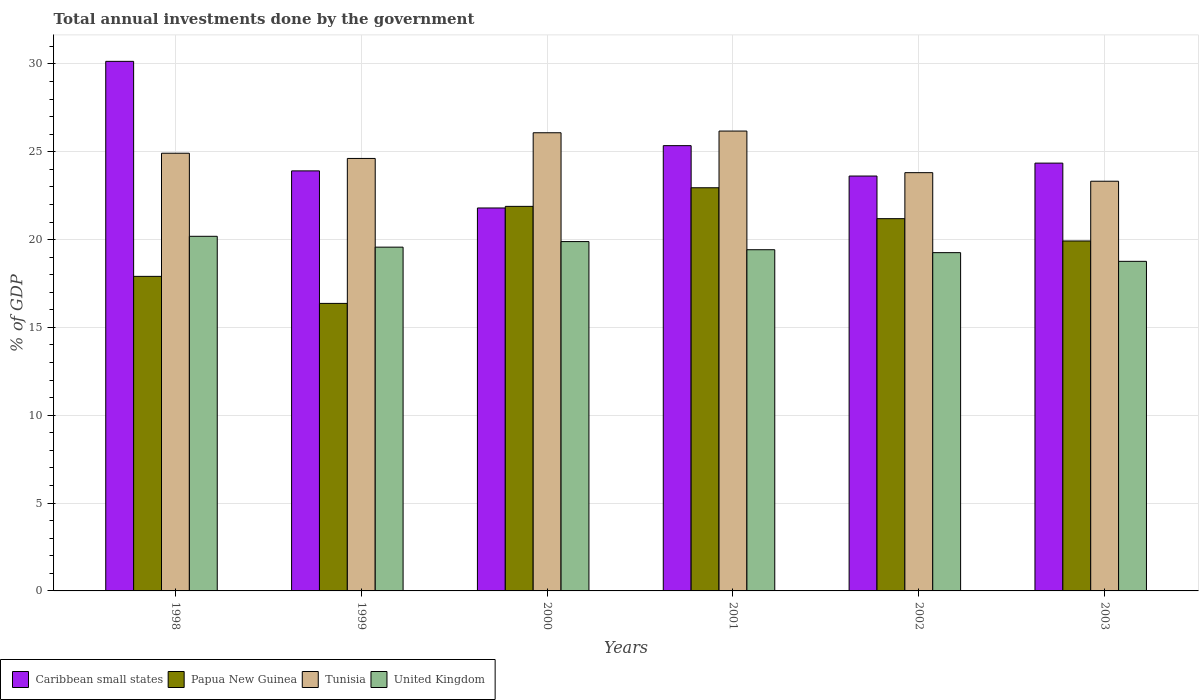How many different coloured bars are there?
Offer a very short reply. 4. How many groups of bars are there?
Make the answer very short. 6. Are the number of bars on each tick of the X-axis equal?
Your answer should be very brief. Yes. How many bars are there on the 3rd tick from the left?
Offer a terse response. 4. How many bars are there on the 5th tick from the right?
Offer a terse response. 4. What is the total annual investments done by the government in Tunisia in 2002?
Provide a short and direct response. 23.81. Across all years, what is the maximum total annual investments done by the government in Papua New Guinea?
Make the answer very short. 22.95. Across all years, what is the minimum total annual investments done by the government in Caribbean small states?
Keep it short and to the point. 21.8. In which year was the total annual investments done by the government in Tunisia minimum?
Keep it short and to the point. 2003. What is the total total annual investments done by the government in Caribbean small states in the graph?
Ensure brevity in your answer.  149.18. What is the difference between the total annual investments done by the government in United Kingdom in 1998 and that in 2000?
Offer a terse response. 0.3. What is the difference between the total annual investments done by the government in Tunisia in 1998 and the total annual investments done by the government in Papua New Guinea in 1999?
Provide a short and direct response. 8.55. What is the average total annual investments done by the government in United Kingdom per year?
Provide a short and direct response. 19.51. In the year 1998, what is the difference between the total annual investments done by the government in Papua New Guinea and total annual investments done by the government in United Kingdom?
Keep it short and to the point. -2.28. In how many years, is the total annual investments done by the government in Caribbean small states greater than 28 %?
Keep it short and to the point. 1. What is the ratio of the total annual investments done by the government in Tunisia in 2000 to that in 2002?
Ensure brevity in your answer.  1.1. What is the difference between the highest and the second highest total annual investments done by the government in United Kingdom?
Make the answer very short. 0.3. What is the difference between the highest and the lowest total annual investments done by the government in Papua New Guinea?
Ensure brevity in your answer.  6.58. In how many years, is the total annual investments done by the government in Tunisia greater than the average total annual investments done by the government in Tunisia taken over all years?
Make the answer very short. 3. What does the 2nd bar from the right in 2001 represents?
Make the answer very short. Tunisia. How many bars are there?
Your answer should be compact. 24. Are all the bars in the graph horizontal?
Your answer should be compact. No. How many years are there in the graph?
Keep it short and to the point. 6. Does the graph contain grids?
Your answer should be very brief. Yes. Where does the legend appear in the graph?
Make the answer very short. Bottom left. What is the title of the graph?
Your response must be concise. Total annual investments done by the government. Does "Ethiopia" appear as one of the legend labels in the graph?
Keep it short and to the point. No. What is the label or title of the Y-axis?
Ensure brevity in your answer.  % of GDP. What is the % of GDP of Caribbean small states in 1998?
Provide a short and direct response. 30.15. What is the % of GDP in Papua New Guinea in 1998?
Your answer should be very brief. 17.91. What is the % of GDP in Tunisia in 1998?
Provide a succinct answer. 24.92. What is the % of GDP of United Kingdom in 1998?
Keep it short and to the point. 20.19. What is the % of GDP in Caribbean small states in 1999?
Your answer should be compact. 23.91. What is the % of GDP of Papua New Guinea in 1999?
Provide a short and direct response. 16.37. What is the % of GDP in Tunisia in 1999?
Keep it short and to the point. 24.62. What is the % of GDP of United Kingdom in 1999?
Your answer should be very brief. 19.57. What is the % of GDP in Caribbean small states in 2000?
Provide a succinct answer. 21.8. What is the % of GDP in Papua New Guinea in 2000?
Keep it short and to the point. 21.89. What is the % of GDP in Tunisia in 2000?
Your response must be concise. 26.08. What is the % of GDP of United Kingdom in 2000?
Ensure brevity in your answer.  19.89. What is the % of GDP in Caribbean small states in 2001?
Offer a very short reply. 25.35. What is the % of GDP in Papua New Guinea in 2001?
Your response must be concise. 22.95. What is the % of GDP in Tunisia in 2001?
Provide a succinct answer. 26.18. What is the % of GDP of United Kingdom in 2001?
Provide a succinct answer. 19.42. What is the % of GDP in Caribbean small states in 2002?
Your answer should be very brief. 23.62. What is the % of GDP of Papua New Guinea in 2002?
Your answer should be compact. 21.19. What is the % of GDP of Tunisia in 2002?
Ensure brevity in your answer.  23.81. What is the % of GDP in United Kingdom in 2002?
Keep it short and to the point. 19.26. What is the % of GDP of Caribbean small states in 2003?
Offer a very short reply. 24.35. What is the % of GDP in Papua New Guinea in 2003?
Make the answer very short. 19.92. What is the % of GDP in Tunisia in 2003?
Your answer should be very brief. 23.32. What is the % of GDP of United Kingdom in 2003?
Ensure brevity in your answer.  18.76. Across all years, what is the maximum % of GDP in Caribbean small states?
Offer a terse response. 30.15. Across all years, what is the maximum % of GDP in Papua New Guinea?
Provide a succinct answer. 22.95. Across all years, what is the maximum % of GDP in Tunisia?
Offer a very short reply. 26.18. Across all years, what is the maximum % of GDP in United Kingdom?
Your answer should be compact. 20.19. Across all years, what is the minimum % of GDP in Caribbean small states?
Your response must be concise. 21.8. Across all years, what is the minimum % of GDP of Papua New Guinea?
Provide a short and direct response. 16.37. Across all years, what is the minimum % of GDP in Tunisia?
Offer a terse response. 23.32. Across all years, what is the minimum % of GDP of United Kingdom?
Provide a succinct answer. 18.76. What is the total % of GDP of Caribbean small states in the graph?
Your response must be concise. 149.18. What is the total % of GDP of Papua New Guinea in the graph?
Your answer should be compact. 120.23. What is the total % of GDP of Tunisia in the graph?
Make the answer very short. 148.93. What is the total % of GDP in United Kingdom in the graph?
Make the answer very short. 117.09. What is the difference between the % of GDP in Caribbean small states in 1998 and that in 1999?
Provide a short and direct response. 6.24. What is the difference between the % of GDP in Papua New Guinea in 1998 and that in 1999?
Provide a succinct answer. 1.54. What is the difference between the % of GDP in Tunisia in 1998 and that in 1999?
Offer a very short reply. 0.3. What is the difference between the % of GDP in United Kingdom in 1998 and that in 1999?
Ensure brevity in your answer.  0.62. What is the difference between the % of GDP of Caribbean small states in 1998 and that in 2000?
Your answer should be compact. 8.35. What is the difference between the % of GDP of Papua New Guinea in 1998 and that in 2000?
Make the answer very short. -3.99. What is the difference between the % of GDP of Tunisia in 1998 and that in 2000?
Give a very brief answer. -1.17. What is the difference between the % of GDP in United Kingdom in 1998 and that in 2000?
Your response must be concise. 0.3. What is the difference between the % of GDP of Caribbean small states in 1998 and that in 2001?
Make the answer very short. 4.8. What is the difference between the % of GDP in Papua New Guinea in 1998 and that in 2001?
Your response must be concise. -5.05. What is the difference between the % of GDP in Tunisia in 1998 and that in 2001?
Offer a terse response. -1.26. What is the difference between the % of GDP of United Kingdom in 1998 and that in 2001?
Make the answer very short. 0.76. What is the difference between the % of GDP in Caribbean small states in 1998 and that in 2002?
Your answer should be compact. 6.53. What is the difference between the % of GDP of Papua New Guinea in 1998 and that in 2002?
Your answer should be very brief. -3.29. What is the difference between the % of GDP in Tunisia in 1998 and that in 2002?
Ensure brevity in your answer.  1.11. What is the difference between the % of GDP in United Kingdom in 1998 and that in 2002?
Provide a short and direct response. 0.93. What is the difference between the % of GDP in Caribbean small states in 1998 and that in 2003?
Your response must be concise. 5.79. What is the difference between the % of GDP of Papua New Guinea in 1998 and that in 2003?
Ensure brevity in your answer.  -2.01. What is the difference between the % of GDP of Tunisia in 1998 and that in 2003?
Your response must be concise. 1.59. What is the difference between the % of GDP in United Kingdom in 1998 and that in 2003?
Give a very brief answer. 1.42. What is the difference between the % of GDP in Caribbean small states in 1999 and that in 2000?
Make the answer very short. 2.11. What is the difference between the % of GDP in Papua New Guinea in 1999 and that in 2000?
Offer a terse response. -5.52. What is the difference between the % of GDP in Tunisia in 1999 and that in 2000?
Offer a terse response. -1.46. What is the difference between the % of GDP in United Kingdom in 1999 and that in 2000?
Your answer should be very brief. -0.32. What is the difference between the % of GDP in Caribbean small states in 1999 and that in 2001?
Offer a very short reply. -1.44. What is the difference between the % of GDP of Papua New Guinea in 1999 and that in 2001?
Ensure brevity in your answer.  -6.58. What is the difference between the % of GDP of Tunisia in 1999 and that in 2001?
Make the answer very short. -1.56. What is the difference between the % of GDP in United Kingdom in 1999 and that in 2001?
Your response must be concise. 0.15. What is the difference between the % of GDP of Caribbean small states in 1999 and that in 2002?
Keep it short and to the point. 0.29. What is the difference between the % of GDP of Papua New Guinea in 1999 and that in 2002?
Offer a terse response. -4.82. What is the difference between the % of GDP of Tunisia in 1999 and that in 2002?
Keep it short and to the point. 0.81. What is the difference between the % of GDP in United Kingdom in 1999 and that in 2002?
Provide a short and direct response. 0.31. What is the difference between the % of GDP in Caribbean small states in 1999 and that in 2003?
Keep it short and to the point. -0.44. What is the difference between the % of GDP of Papua New Guinea in 1999 and that in 2003?
Give a very brief answer. -3.55. What is the difference between the % of GDP in Tunisia in 1999 and that in 2003?
Your answer should be very brief. 1.3. What is the difference between the % of GDP of United Kingdom in 1999 and that in 2003?
Provide a short and direct response. 0.81. What is the difference between the % of GDP in Caribbean small states in 2000 and that in 2001?
Give a very brief answer. -3.55. What is the difference between the % of GDP of Papua New Guinea in 2000 and that in 2001?
Offer a very short reply. -1.06. What is the difference between the % of GDP of Tunisia in 2000 and that in 2001?
Offer a terse response. -0.1. What is the difference between the % of GDP in United Kingdom in 2000 and that in 2001?
Your answer should be very brief. 0.46. What is the difference between the % of GDP in Caribbean small states in 2000 and that in 2002?
Ensure brevity in your answer.  -1.82. What is the difference between the % of GDP in Tunisia in 2000 and that in 2002?
Offer a very short reply. 2.27. What is the difference between the % of GDP of United Kingdom in 2000 and that in 2002?
Keep it short and to the point. 0.63. What is the difference between the % of GDP of Caribbean small states in 2000 and that in 2003?
Your response must be concise. -2.55. What is the difference between the % of GDP of Papua New Guinea in 2000 and that in 2003?
Your answer should be very brief. 1.97. What is the difference between the % of GDP of Tunisia in 2000 and that in 2003?
Offer a terse response. 2.76. What is the difference between the % of GDP in United Kingdom in 2000 and that in 2003?
Make the answer very short. 1.12. What is the difference between the % of GDP in Caribbean small states in 2001 and that in 2002?
Make the answer very short. 1.73. What is the difference between the % of GDP in Papua New Guinea in 2001 and that in 2002?
Offer a terse response. 1.76. What is the difference between the % of GDP in Tunisia in 2001 and that in 2002?
Offer a terse response. 2.37. What is the difference between the % of GDP of United Kingdom in 2001 and that in 2002?
Make the answer very short. 0.17. What is the difference between the % of GDP of Papua New Guinea in 2001 and that in 2003?
Your response must be concise. 3.03. What is the difference between the % of GDP of Tunisia in 2001 and that in 2003?
Ensure brevity in your answer.  2.86. What is the difference between the % of GDP in United Kingdom in 2001 and that in 2003?
Provide a succinct answer. 0.66. What is the difference between the % of GDP of Caribbean small states in 2002 and that in 2003?
Make the answer very short. -0.74. What is the difference between the % of GDP of Papua New Guinea in 2002 and that in 2003?
Make the answer very short. 1.27. What is the difference between the % of GDP of Tunisia in 2002 and that in 2003?
Keep it short and to the point. 0.49. What is the difference between the % of GDP in United Kingdom in 2002 and that in 2003?
Keep it short and to the point. 0.49. What is the difference between the % of GDP of Caribbean small states in 1998 and the % of GDP of Papua New Guinea in 1999?
Give a very brief answer. 13.78. What is the difference between the % of GDP of Caribbean small states in 1998 and the % of GDP of Tunisia in 1999?
Provide a short and direct response. 5.53. What is the difference between the % of GDP of Caribbean small states in 1998 and the % of GDP of United Kingdom in 1999?
Give a very brief answer. 10.58. What is the difference between the % of GDP in Papua New Guinea in 1998 and the % of GDP in Tunisia in 1999?
Offer a very short reply. -6.71. What is the difference between the % of GDP in Papua New Guinea in 1998 and the % of GDP in United Kingdom in 1999?
Offer a terse response. -1.66. What is the difference between the % of GDP of Tunisia in 1998 and the % of GDP of United Kingdom in 1999?
Offer a terse response. 5.35. What is the difference between the % of GDP of Caribbean small states in 1998 and the % of GDP of Papua New Guinea in 2000?
Provide a short and direct response. 8.26. What is the difference between the % of GDP in Caribbean small states in 1998 and the % of GDP in Tunisia in 2000?
Your response must be concise. 4.06. What is the difference between the % of GDP of Caribbean small states in 1998 and the % of GDP of United Kingdom in 2000?
Offer a terse response. 10.26. What is the difference between the % of GDP in Papua New Guinea in 1998 and the % of GDP in Tunisia in 2000?
Offer a terse response. -8.18. What is the difference between the % of GDP of Papua New Guinea in 1998 and the % of GDP of United Kingdom in 2000?
Keep it short and to the point. -1.98. What is the difference between the % of GDP in Tunisia in 1998 and the % of GDP in United Kingdom in 2000?
Provide a short and direct response. 5.03. What is the difference between the % of GDP of Caribbean small states in 1998 and the % of GDP of Papua New Guinea in 2001?
Your response must be concise. 7.2. What is the difference between the % of GDP of Caribbean small states in 1998 and the % of GDP of Tunisia in 2001?
Offer a terse response. 3.97. What is the difference between the % of GDP in Caribbean small states in 1998 and the % of GDP in United Kingdom in 2001?
Your answer should be compact. 10.72. What is the difference between the % of GDP in Papua New Guinea in 1998 and the % of GDP in Tunisia in 2001?
Ensure brevity in your answer.  -8.27. What is the difference between the % of GDP of Papua New Guinea in 1998 and the % of GDP of United Kingdom in 2001?
Ensure brevity in your answer.  -1.52. What is the difference between the % of GDP in Tunisia in 1998 and the % of GDP in United Kingdom in 2001?
Your answer should be very brief. 5.49. What is the difference between the % of GDP in Caribbean small states in 1998 and the % of GDP in Papua New Guinea in 2002?
Provide a short and direct response. 8.96. What is the difference between the % of GDP of Caribbean small states in 1998 and the % of GDP of Tunisia in 2002?
Ensure brevity in your answer.  6.34. What is the difference between the % of GDP of Caribbean small states in 1998 and the % of GDP of United Kingdom in 2002?
Provide a succinct answer. 10.89. What is the difference between the % of GDP in Papua New Guinea in 1998 and the % of GDP in Tunisia in 2002?
Offer a very short reply. -5.9. What is the difference between the % of GDP of Papua New Guinea in 1998 and the % of GDP of United Kingdom in 2002?
Your answer should be very brief. -1.35. What is the difference between the % of GDP in Tunisia in 1998 and the % of GDP in United Kingdom in 2002?
Your response must be concise. 5.66. What is the difference between the % of GDP in Caribbean small states in 1998 and the % of GDP in Papua New Guinea in 2003?
Provide a succinct answer. 10.23. What is the difference between the % of GDP of Caribbean small states in 1998 and the % of GDP of Tunisia in 2003?
Your answer should be compact. 6.82. What is the difference between the % of GDP of Caribbean small states in 1998 and the % of GDP of United Kingdom in 2003?
Offer a very short reply. 11.38. What is the difference between the % of GDP in Papua New Guinea in 1998 and the % of GDP in Tunisia in 2003?
Offer a terse response. -5.42. What is the difference between the % of GDP of Papua New Guinea in 1998 and the % of GDP of United Kingdom in 2003?
Give a very brief answer. -0.86. What is the difference between the % of GDP in Tunisia in 1998 and the % of GDP in United Kingdom in 2003?
Make the answer very short. 6.15. What is the difference between the % of GDP in Caribbean small states in 1999 and the % of GDP in Papua New Guinea in 2000?
Offer a terse response. 2.02. What is the difference between the % of GDP of Caribbean small states in 1999 and the % of GDP of Tunisia in 2000?
Provide a short and direct response. -2.17. What is the difference between the % of GDP of Caribbean small states in 1999 and the % of GDP of United Kingdom in 2000?
Ensure brevity in your answer.  4.03. What is the difference between the % of GDP of Papua New Guinea in 1999 and the % of GDP of Tunisia in 2000?
Make the answer very short. -9.71. What is the difference between the % of GDP in Papua New Guinea in 1999 and the % of GDP in United Kingdom in 2000?
Your answer should be compact. -3.52. What is the difference between the % of GDP in Tunisia in 1999 and the % of GDP in United Kingdom in 2000?
Your response must be concise. 4.73. What is the difference between the % of GDP in Caribbean small states in 1999 and the % of GDP in Papua New Guinea in 2001?
Ensure brevity in your answer.  0.96. What is the difference between the % of GDP of Caribbean small states in 1999 and the % of GDP of Tunisia in 2001?
Provide a succinct answer. -2.27. What is the difference between the % of GDP in Caribbean small states in 1999 and the % of GDP in United Kingdom in 2001?
Your answer should be very brief. 4.49. What is the difference between the % of GDP in Papua New Guinea in 1999 and the % of GDP in Tunisia in 2001?
Provide a short and direct response. -9.81. What is the difference between the % of GDP in Papua New Guinea in 1999 and the % of GDP in United Kingdom in 2001?
Provide a short and direct response. -3.06. What is the difference between the % of GDP of Tunisia in 1999 and the % of GDP of United Kingdom in 2001?
Keep it short and to the point. 5.2. What is the difference between the % of GDP of Caribbean small states in 1999 and the % of GDP of Papua New Guinea in 2002?
Make the answer very short. 2.72. What is the difference between the % of GDP in Caribbean small states in 1999 and the % of GDP in Tunisia in 2002?
Make the answer very short. 0.1. What is the difference between the % of GDP in Caribbean small states in 1999 and the % of GDP in United Kingdom in 2002?
Make the answer very short. 4.66. What is the difference between the % of GDP in Papua New Guinea in 1999 and the % of GDP in Tunisia in 2002?
Provide a succinct answer. -7.44. What is the difference between the % of GDP in Papua New Guinea in 1999 and the % of GDP in United Kingdom in 2002?
Your answer should be very brief. -2.89. What is the difference between the % of GDP in Tunisia in 1999 and the % of GDP in United Kingdom in 2002?
Give a very brief answer. 5.36. What is the difference between the % of GDP in Caribbean small states in 1999 and the % of GDP in Papua New Guinea in 2003?
Make the answer very short. 3.99. What is the difference between the % of GDP in Caribbean small states in 1999 and the % of GDP in Tunisia in 2003?
Ensure brevity in your answer.  0.59. What is the difference between the % of GDP in Caribbean small states in 1999 and the % of GDP in United Kingdom in 2003?
Make the answer very short. 5.15. What is the difference between the % of GDP of Papua New Guinea in 1999 and the % of GDP of Tunisia in 2003?
Provide a short and direct response. -6.95. What is the difference between the % of GDP in Papua New Guinea in 1999 and the % of GDP in United Kingdom in 2003?
Offer a terse response. -2.39. What is the difference between the % of GDP in Tunisia in 1999 and the % of GDP in United Kingdom in 2003?
Keep it short and to the point. 5.86. What is the difference between the % of GDP in Caribbean small states in 2000 and the % of GDP in Papua New Guinea in 2001?
Offer a terse response. -1.15. What is the difference between the % of GDP of Caribbean small states in 2000 and the % of GDP of Tunisia in 2001?
Your answer should be compact. -4.38. What is the difference between the % of GDP of Caribbean small states in 2000 and the % of GDP of United Kingdom in 2001?
Your answer should be compact. 2.38. What is the difference between the % of GDP in Papua New Guinea in 2000 and the % of GDP in Tunisia in 2001?
Offer a very short reply. -4.29. What is the difference between the % of GDP in Papua New Guinea in 2000 and the % of GDP in United Kingdom in 2001?
Offer a very short reply. 2.47. What is the difference between the % of GDP of Tunisia in 2000 and the % of GDP of United Kingdom in 2001?
Offer a terse response. 6.66. What is the difference between the % of GDP in Caribbean small states in 2000 and the % of GDP in Papua New Guinea in 2002?
Your response must be concise. 0.61. What is the difference between the % of GDP in Caribbean small states in 2000 and the % of GDP in Tunisia in 2002?
Offer a terse response. -2.01. What is the difference between the % of GDP of Caribbean small states in 2000 and the % of GDP of United Kingdom in 2002?
Your response must be concise. 2.54. What is the difference between the % of GDP of Papua New Guinea in 2000 and the % of GDP of Tunisia in 2002?
Your answer should be very brief. -1.92. What is the difference between the % of GDP of Papua New Guinea in 2000 and the % of GDP of United Kingdom in 2002?
Provide a short and direct response. 2.63. What is the difference between the % of GDP in Tunisia in 2000 and the % of GDP in United Kingdom in 2002?
Make the answer very short. 6.83. What is the difference between the % of GDP of Caribbean small states in 2000 and the % of GDP of Papua New Guinea in 2003?
Provide a succinct answer. 1.88. What is the difference between the % of GDP of Caribbean small states in 2000 and the % of GDP of Tunisia in 2003?
Offer a very short reply. -1.52. What is the difference between the % of GDP in Caribbean small states in 2000 and the % of GDP in United Kingdom in 2003?
Provide a short and direct response. 3.04. What is the difference between the % of GDP of Papua New Guinea in 2000 and the % of GDP of Tunisia in 2003?
Offer a very short reply. -1.43. What is the difference between the % of GDP in Papua New Guinea in 2000 and the % of GDP in United Kingdom in 2003?
Offer a terse response. 3.13. What is the difference between the % of GDP of Tunisia in 2000 and the % of GDP of United Kingdom in 2003?
Ensure brevity in your answer.  7.32. What is the difference between the % of GDP in Caribbean small states in 2001 and the % of GDP in Papua New Guinea in 2002?
Give a very brief answer. 4.16. What is the difference between the % of GDP of Caribbean small states in 2001 and the % of GDP of Tunisia in 2002?
Ensure brevity in your answer.  1.54. What is the difference between the % of GDP in Caribbean small states in 2001 and the % of GDP in United Kingdom in 2002?
Provide a short and direct response. 6.09. What is the difference between the % of GDP of Papua New Guinea in 2001 and the % of GDP of Tunisia in 2002?
Offer a terse response. -0.86. What is the difference between the % of GDP in Papua New Guinea in 2001 and the % of GDP in United Kingdom in 2002?
Offer a very short reply. 3.69. What is the difference between the % of GDP in Tunisia in 2001 and the % of GDP in United Kingdom in 2002?
Your answer should be very brief. 6.92. What is the difference between the % of GDP of Caribbean small states in 2001 and the % of GDP of Papua New Guinea in 2003?
Provide a succinct answer. 5.43. What is the difference between the % of GDP in Caribbean small states in 2001 and the % of GDP in Tunisia in 2003?
Ensure brevity in your answer.  2.03. What is the difference between the % of GDP in Caribbean small states in 2001 and the % of GDP in United Kingdom in 2003?
Ensure brevity in your answer.  6.59. What is the difference between the % of GDP of Papua New Guinea in 2001 and the % of GDP of Tunisia in 2003?
Give a very brief answer. -0.37. What is the difference between the % of GDP of Papua New Guinea in 2001 and the % of GDP of United Kingdom in 2003?
Offer a very short reply. 4.19. What is the difference between the % of GDP in Tunisia in 2001 and the % of GDP in United Kingdom in 2003?
Your response must be concise. 7.42. What is the difference between the % of GDP of Caribbean small states in 2002 and the % of GDP of Papua New Guinea in 2003?
Give a very brief answer. 3.7. What is the difference between the % of GDP in Caribbean small states in 2002 and the % of GDP in Tunisia in 2003?
Your response must be concise. 0.3. What is the difference between the % of GDP of Caribbean small states in 2002 and the % of GDP of United Kingdom in 2003?
Your response must be concise. 4.86. What is the difference between the % of GDP in Papua New Guinea in 2002 and the % of GDP in Tunisia in 2003?
Ensure brevity in your answer.  -2.13. What is the difference between the % of GDP in Papua New Guinea in 2002 and the % of GDP in United Kingdom in 2003?
Provide a succinct answer. 2.43. What is the difference between the % of GDP of Tunisia in 2002 and the % of GDP of United Kingdom in 2003?
Your answer should be compact. 5.05. What is the average % of GDP in Caribbean small states per year?
Your answer should be compact. 24.86. What is the average % of GDP of Papua New Guinea per year?
Offer a terse response. 20.04. What is the average % of GDP of Tunisia per year?
Your response must be concise. 24.82. What is the average % of GDP in United Kingdom per year?
Offer a terse response. 19.51. In the year 1998, what is the difference between the % of GDP of Caribbean small states and % of GDP of Papua New Guinea?
Give a very brief answer. 12.24. In the year 1998, what is the difference between the % of GDP of Caribbean small states and % of GDP of Tunisia?
Your answer should be very brief. 5.23. In the year 1998, what is the difference between the % of GDP of Caribbean small states and % of GDP of United Kingdom?
Provide a succinct answer. 9.96. In the year 1998, what is the difference between the % of GDP of Papua New Guinea and % of GDP of Tunisia?
Your response must be concise. -7.01. In the year 1998, what is the difference between the % of GDP in Papua New Guinea and % of GDP in United Kingdom?
Your response must be concise. -2.28. In the year 1998, what is the difference between the % of GDP in Tunisia and % of GDP in United Kingdom?
Give a very brief answer. 4.73. In the year 1999, what is the difference between the % of GDP in Caribbean small states and % of GDP in Papua New Guinea?
Keep it short and to the point. 7.54. In the year 1999, what is the difference between the % of GDP of Caribbean small states and % of GDP of Tunisia?
Your answer should be very brief. -0.71. In the year 1999, what is the difference between the % of GDP in Caribbean small states and % of GDP in United Kingdom?
Make the answer very short. 4.34. In the year 1999, what is the difference between the % of GDP in Papua New Guinea and % of GDP in Tunisia?
Your answer should be very brief. -8.25. In the year 1999, what is the difference between the % of GDP of Papua New Guinea and % of GDP of United Kingdom?
Keep it short and to the point. -3.2. In the year 1999, what is the difference between the % of GDP of Tunisia and % of GDP of United Kingdom?
Provide a succinct answer. 5.05. In the year 2000, what is the difference between the % of GDP of Caribbean small states and % of GDP of Papua New Guinea?
Provide a succinct answer. -0.09. In the year 2000, what is the difference between the % of GDP of Caribbean small states and % of GDP of Tunisia?
Provide a short and direct response. -4.28. In the year 2000, what is the difference between the % of GDP of Caribbean small states and % of GDP of United Kingdom?
Your answer should be compact. 1.91. In the year 2000, what is the difference between the % of GDP in Papua New Guinea and % of GDP in Tunisia?
Offer a terse response. -4.19. In the year 2000, what is the difference between the % of GDP in Papua New Guinea and % of GDP in United Kingdom?
Give a very brief answer. 2. In the year 2000, what is the difference between the % of GDP of Tunisia and % of GDP of United Kingdom?
Your answer should be very brief. 6.2. In the year 2001, what is the difference between the % of GDP of Caribbean small states and % of GDP of Papua New Guinea?
Ensure brevity in your answer.  2.4. In the year 2001, what is the difference between the % of GDP of Caribbean small states and % of GDP of Tunisia?
Provide a short and direct response. -0.83. In the year 2001, what is the difference between the % of GDP in Caribbean small states and % of GDP in United Kingdom?
Your response must be concise. 5.92. In the year 2001, what is the difference between the % of GDP in Papua New Guinea and % of GDP in Tunisia?
Your response must be concise. -3.23. In the year 2001, what is the difference between the % of GDP of Papua New Guinea and % of GDP of United Kingdom?
Ensure brevity in your answer.  3.53. In the year 2001, what is the difference between the % of GDP in Tunisia and % of GDP in United Kingdom?
Keep it short and to the point. 6.76. In the year 2002, what is the difference between the % of GDP of Caribbean small states and % of GDP of Papua New Guinea?
Your answer should be very brief. 2.43. In the year 2002, what is the difference between the % of GDP in Caribbean small states and % of GDP in Tunisia?
Your answer should be very brief. -0.19. In the year 2002, what is the difference between the % of GDP in Caribbean small states and % of GDP in United Kingdom?
Ensure brevity in your answer.  4.36. In the year 2002, what is the difference between the % of GDP in Papua New Guinea and % of GDP in Tunisia?
Provide a succinct answer. -2.62. In the year 2002, what is the difference between the % of GDP of Papua New Guinea and % of GDP of United Kingdom?
Make the answer very short. 1.94. In the year 2002, what is the difference between the % of GDP of Tunisia and % of GDP of United Kingdom?
Offer a terse response. 4.55. In the year 2003, what is the difference between the % of GDP of Caribbean small states and % of GDP of Papua New Guinea?
Your answer should be compact. 4.43. In the year 2003, what is the difference between the % of GDP in Caribbean small states and % of GDP in Tunisia?
Provide a short and direct response. 1.03. In the year 2003, what is the difference between the % of GDP of Caribbean small states and % of GDP of United Kingdom?
Offer a terse response. 5.59. In the year 2003, what is the difference between the % of GDP in Papua New Guinea and % of GDP in Tunisia?
Provide a succinct answer. -3.4. In the year 2003, what is the difference between the % of GDP in Papua New Guinea and % of GDP in United Kingdom?
Make the answer very short. 1.16. In the year 2003, what is the difference between the % of GDP of Tunisia and % of GDP of United Kingdom?
Keep it short and to the point. 4.56. What is the ratio of the % of GDP of Caribbean small states in 1998 to that in 1999?
Provide a succinct answer. 1.26. What is the ratio of the % of GDP of Papua New Guinea in 1998 to that in 1999?
Your response must be concise. 1.09. What is the ratio of the % of GDP in Tunisia in 1998 to that in 1999?
Provide a short and direct response. 1.01. What is the ratio of the % of GDP of United Kingdom in 1998 to that in 1999?
Give a very brief answer. 1.03. What is the ratio of the % of GDP in Caribbean small states in 1998 to that in 2000?
Your answer should be compact. 1.38. What is the ratio of the % of GDP in Papua New Guinea in 1998 to that in 2000?
Provide a succinct answer. 0.82. What is the ratio of the % of GDP of Tunisia in 1998 to that in 2000?
Your answer should be compact. 0.96. What is the ratio of the % of GDP in United Kingdom in 1998 to that in 2000?
Offer a terse response. 1.02. What is the ratio of the % of GDP in Caribbean small states in 1998 to that in 2001?
Your answer should be very brief. 1.19. What is the ratio of the % of GDP in Papua New Guinea in 1998 to that in 2001?
Your answer should be compact. 0.78. What is the ratio of the % of GDP of Tunisia in 1998 to that in 2001?
Give a very brief answer. 0.95. What is the ratio of the % of GDP of United Kingdom in 1998 to that in 2001?
Your response must be concise. 1.04. What is the ratio of the % of GDP in Caribbean small states in 1998 to that in 2002?
Provide a short and direct response. 1.28. What is the ratio of the % of GDP of Papua New Guinea in 1998 to that in 2002?
Your response must be concise. 0.84. What is the ratio of the % of GDP of Tunisia in 1998 to that in 2002?
Provide a short and direct response. 1.05. What is the ratio of the % of GDP of United Kingdom in 1998 to that in 2002?
Give a very brief answer. 1.05. What is the ratio of the % of GDP in Caribbean small states in 1998 to that in 2003?
Your answer should be compact. 1.24. What is the ratio of the % of GDP in Papua New Guinea in 1998 to that in 2003?
Your answer should be compact. 0.9. What is the ratio of the % of GDP in Tunisia in 1998 to that in 2003?
Your answer should be compact. 1.07. What is the ratio of the % of GDP in United Kingdom in 1998 to that in 2003?
Make the answer very short. 1.08. What is the ratio of the % of GDP of Caribbean small states in 1999 to that in 2000?
Provide a succinct answer. 1.1. What is the ratio of the % of GDP of Papua New Guinea in 1999 to that in 2000?
Provide a short and direct response. 0.75. What is the ratio of the % of GDP of Tunisia in 1999 to that in 2000?
Provide a short and direct response. 0.94. What is the ratio of the % of GDP in United Kingdom in 1999 to that in 2000?
Offer a terse response. 0.98. What is the ratio of the % of GDP in Caribbean small states in 1999 to that in 2001?
Ensure brevity in your answer.  0.94. What is the ratio of the % of GDP in Papua New Guinea in 1999 to that in 2001?
Provide a succinct answer. 0.71. What is the ratio of the % of GDP in Tunisia in 1999 to that in 2001?
Make the answer very short. 0.94. What is the ratio of the % of GDP in United Kingdom in 1999 to that in 2001?
Ensure brevity in your answer.  1.01. What is the ratio of the % of GDP of Caribbean small states in 1999 to that in 2002?
Your response must be concise. 1.01. What is the ratio of the % of GDP in Papua New Guinea in 1999 to that in 2002?
Offer a terse response. 0.77. What is the ratio of the % of GDP in Tunisia in 1999 to that in 2002?
Make the answer very short. 1.03. What is the ratio of the % of GDP in United Kingdom in 1999 to that in 2002?
Make the answer very short. 1.02. What is the ratio of the % of GDP in Caribbean small states in 1999 to that in 2003?
Give a very brief answer. 0.98. What is the ratio of the % of GDP in Papua New Guinea in 1999 to that in 2003?
Provide a short and direct response. 0.82. What is the ratio of the % of GDP of Tunisia in 1999 to that in 2003?
Make the answer very short. 1.06. What is the ratio of the % of GDP of United Kingdom in 1999 to that in 2003?
Your answer should be compact. 1.04. What is the ratio of the % of GDP in Caribbean small states in 2000 to that in 2001?
Make the answer very short. 0.86. What is the ratio of the % of GDP in Papua New Guinea in 2000 to that in 2001?
Offer a very short reply. 0.95. What is the ratio of the % of GDP of Tunisia in 2000 to that in 2001?
Keep it short and to the point. 1. What is the ratio of the % of GDP of United Kingdom in 2000 to that in 2001?
Provide a short and direct response. 1.02. What is the ratio of the % of GDP in Caribbean small states in 2000 to that in 2002?
Make the answer very short. 0.92. What is the ratio of the % of GDP of Papua New Guinea in 2000 to that in 2002?
Your response must be concise. 1.03. What is the ratio of the % of GDP in Tunisia in 2000 to that in 2002?
Offer a terse response. 1.1. What is the ratio of the % of GDP in United Kingdom in 2000 to that in 2002?
Provide a short and direct response. 1.03. What is the ratio of the % of GDP of Caribbean small states in 2000 to that in 2003?
Offer a very short reply. 0.9. What is the ratio of the % of GDP of Papua New Guinea in 2000 to that in 2003?
Offer a terse response. 1.1. What is the ratio of the % of GDP of Tunisia in 2000 to that in 2003?
Your answer should be very brief. 1.12. What is the ratio of the % of GDP in United Kingdom in 2000 to that in 2003?
Your answer should be very brief. 1.06. What is the ratio of the % of GDP of Caribbean small states in 2001 to that in 2002?
Your response must be concise. 1.07. What is the ratio of the % of GDP of Papua New Guinea in 2001 to that in 2002?
Offer a terse response. 1.08. What is the ratio of the % of GDP in Tunisia in 2001 to that in 2002?
Provide a short and direct response. 1.1. What is the ratio of the % of GDP of United Kingdom in 2001 to that in 2002?
Give a very brief answer. 1.01. What is the ratio of the % of GDP of Caribbean small states in 2001 to that in 2003?
Give a very brief answer. 1.04. What is the ratio of the % of GDP in Papua New Guinea in 2001 to that in 2003?
Keep it short and to the point. 1.15. What is the ratio of the % of GDP of Tunisia in 2001 to that in 2003?
Your response must be concise. 1.12. What is the ratio of the % of GDP in United Kingdom in 2001 to that in 2003?
Keep it short and to the point. 1.04. What is the ratio of the % of GDP in Caribbean small states in 2002 to that in 2003?
Give a very brief answer. 0.97. What is the ratio of the % of GDP of Papua New Guinea in 2002 to that in 2003?
Your answer should be very brief. 1.06. What is the ratio of the % of GDP in Tunisia in 2002 to that in 2003?
Your answer should be compact. 1.02. What is the ratio of the % of GDP of United Kingdom in 2002 to that in 2003?
Your answer should be compact. 1.03. What is the difference between the highest and the second highest % of GDP in Caribbean small states?
Offer a terse response. 4.8. What is the difference between the highest and the second highest % of GDP of Papua New Guinea?
Ensure brevity in your answer.  1.06. What is the difference between the highest and the second highest % of GDP in Tunisia?
Make the answer very short. 0.1. What is the difference between the highest and the second highest % of GDP of United Kingdom?
Ensure brevity in your answer.  0.3. What is the difference between the highest and the lowest % of GDP in Caribbean small states?
Offer a terse response. 8.35. What is the difference between the highest and the lowest % of GDP of Papua New Guinea?
Keep it short and to the point. 6.58. What is the difference between the highest and the lowest % of GDP in Tunisia?
Provide a short and direct response. 2.86. What is the difference between the highest and the lowest % of GDP in United Kingdom?
Make the answer very short. 1.42. 